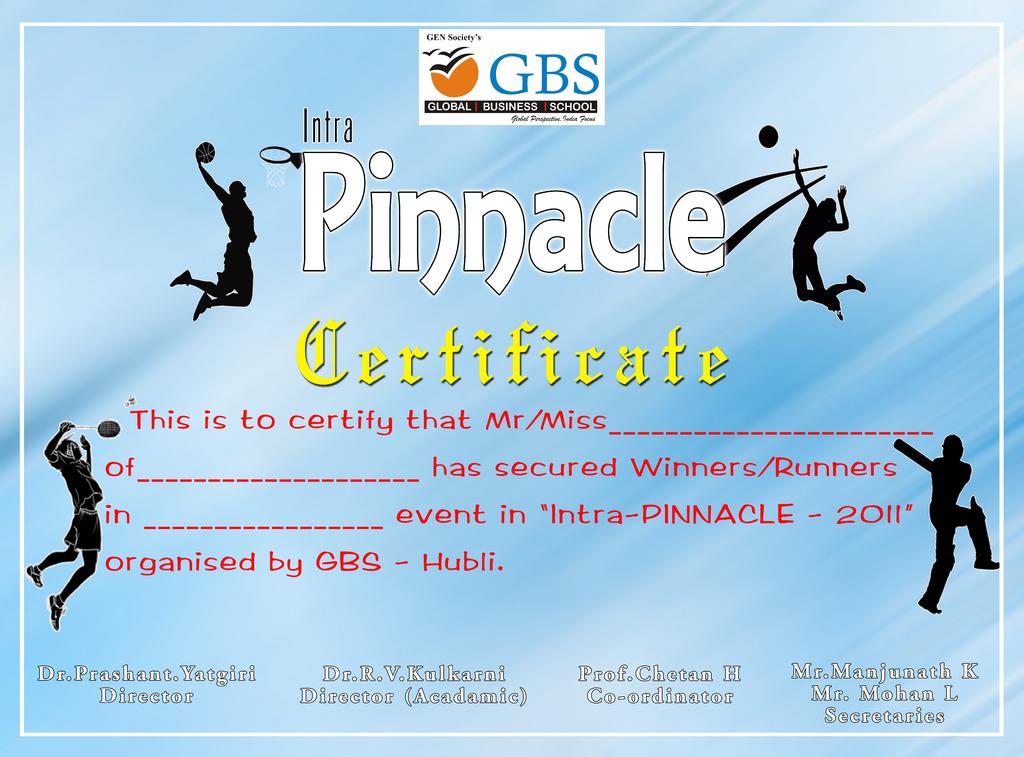What type of certificate is this?
Ensure brevity in your answer.  Pinnacle. What are the letters in blue at the very top?
Your answer should be very brief. Gbs. 